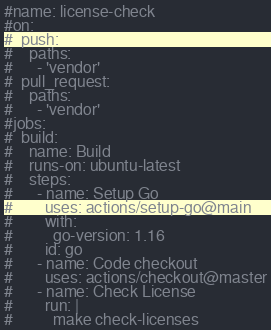Convert code to text. <code><loc_0><loc_0><loc_500><loc_500><_YAML_>#name: license-check
#on:
#  push:
#    paths:
#      - 'vendor'
#  pull_request:
#    paths:
#      - 'vendor'
#jobs:
#  build:
#    name: Build
#    runs-on: ubuntu-latest
#    steps:
#      - name: Setup Go
#        uses: actions/setup-go@main
#        with:
#          go-version: 1.16
#        id: go
#      - name: Code checkout
#        uses: actions/checkout@master
#      - name: Check License
#        run: |
#          make check-licenses
</code> 